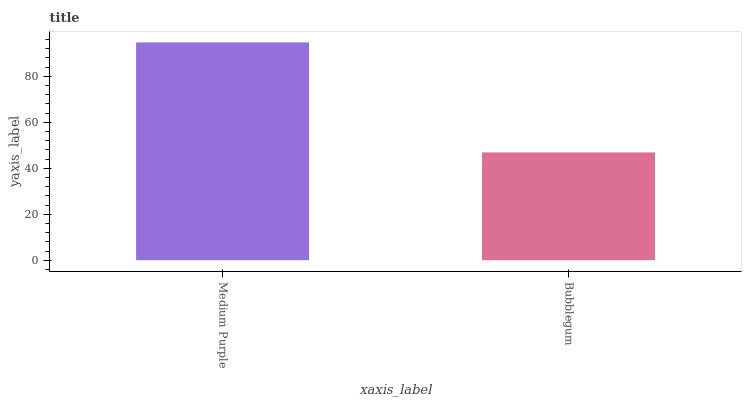Is Bubblegum the minimum?
Answer yes or no. Yes. Is Medium Purple the maximum?
Answer yes or no. Yes. Is Bubblegum the maximum?
Answer yes or no. No. Is Medium Purple greater than Bubblegum?
Answer yes or no. Yes. Is Bubblegum less than Medium Purple?
Answer yes or no. Yes. Is Bubblegum greater than Medium Purple?
Answer yes or no. No. Is Medium Purple less than Bubblegum?
Answer yes or no. No. Is Medium Purple the high median?
Answer yes or no. Yes. Is Bubblegum the low median?
Answer yes or no. Yes. Is Bubblegum the high median?
Answer yes or no. No. Is Medium Purple the low median?
Answer yes or no. No. 